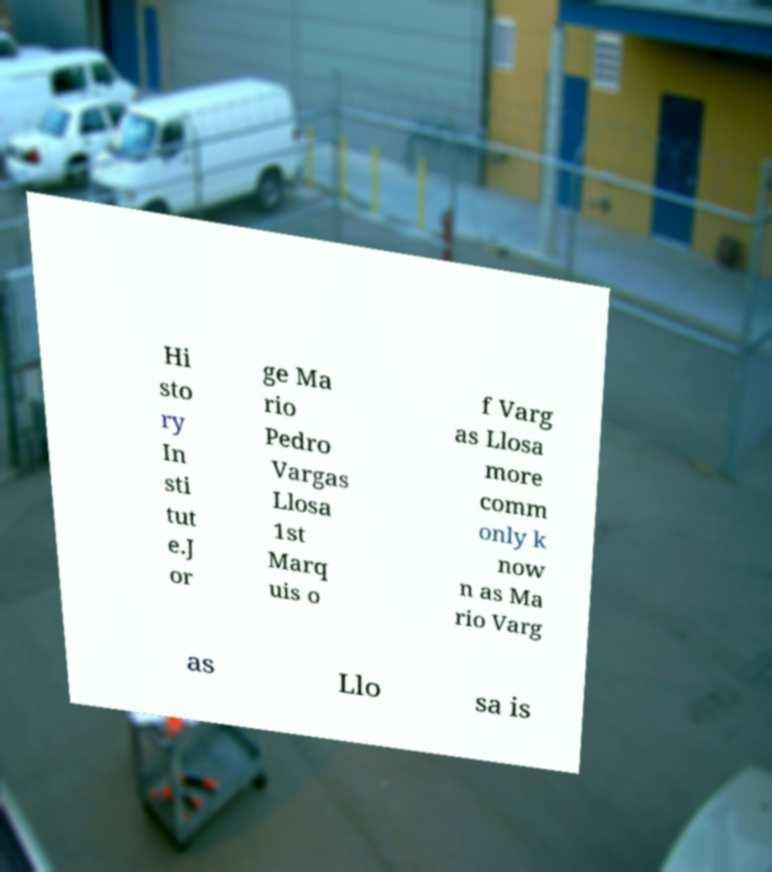There's text embedded in this image that I need extracted. Can you transcribe it verbatim? Hi sto ry In sti tut e.J or ge Ma rio Pedro Vargas Llosa 1st Marq uis o f Varg as Llosa more comm only k now n as Ma rio Varg as Llo sa is 